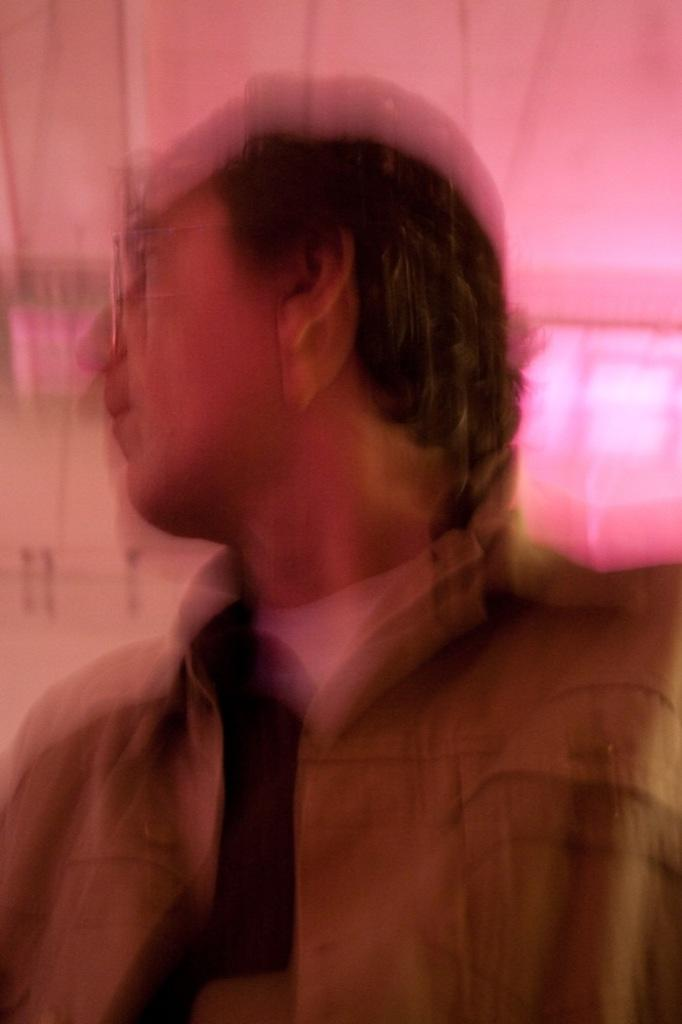What is present in the image? There is a person in the image. Can you describe the person's appearance? The person is wearing clothes and spectacles. What type of knife is the person using in the image? There is no knife present in the image. What word is the person saying in the image? The image does not show the person speaking or provide any indication of the word they might be saying. 